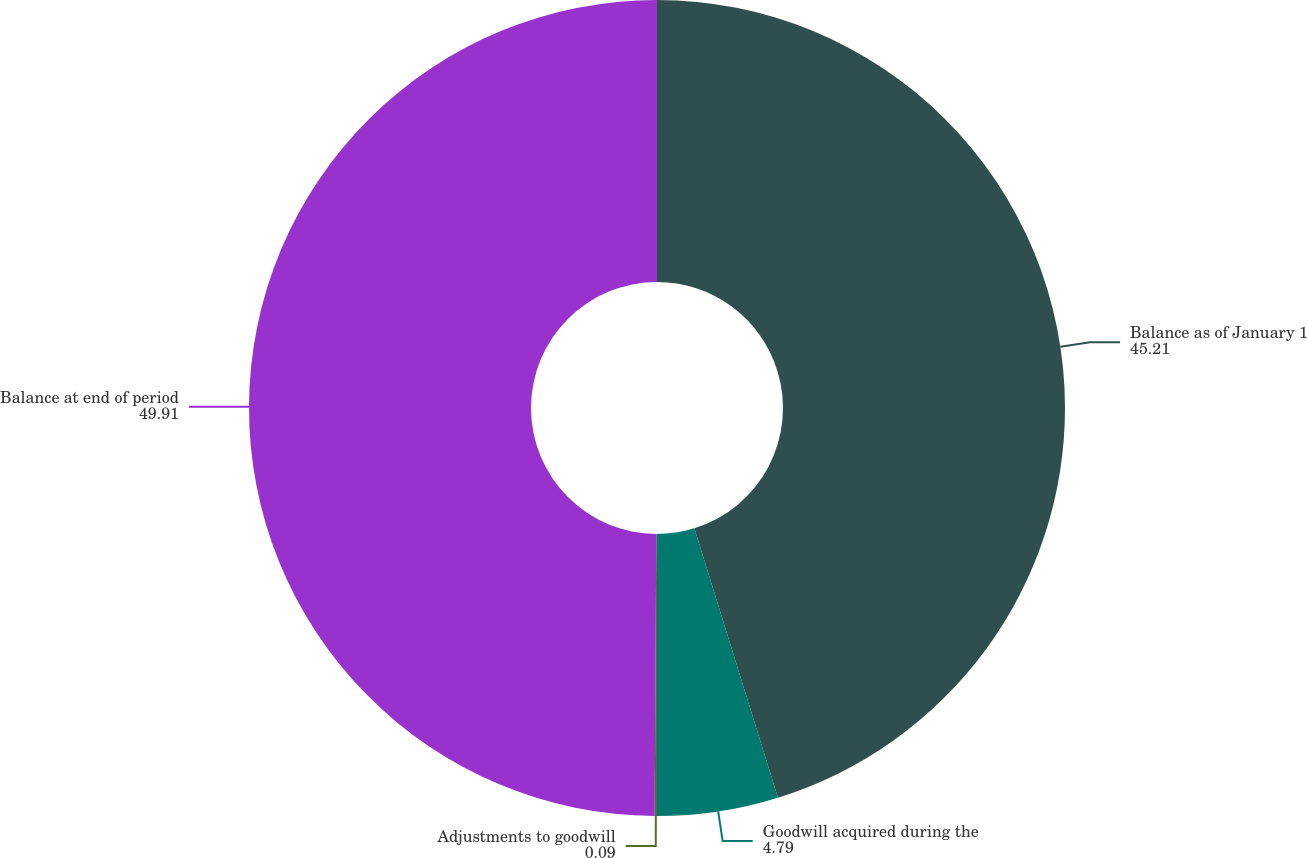Convert chart to OTSL. <chart><loc_0><loc_0><loc_500><loc_500><pie_chart><fcel>Balance as of January 1<fcel>Goodwill acquired during the<fcel>Adjustments to goodwill<fcel>Balance at end of period<nl><fcel>45.21%<fcel>4.79%<fcel>0.09%<fcel>49.91%<nl></chart> 